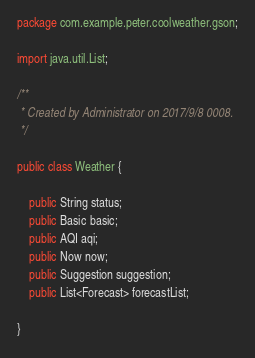<code> <loc_0><loc_0><loc_500><loc_500><_Java_>package com.example.peter.coolweather.gson;

import java.util.List;

/**
 * Created by Administrator on 2017/9/8 0008.
 */

public class Weather {

    public String status;
    public Basic basic;
    public AQI aqi;
    public Now now;
    public Suggestion suggestion;
    public List<Forecast> forecastList;

}
</code> 